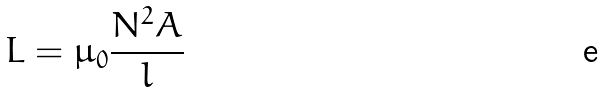Convert formula to latex. <formula><loc_0><loc_0><loc_500><loc_500>L = \mu _ { 0 } \frac { N ^ { 2 } A } { l }</formula> 